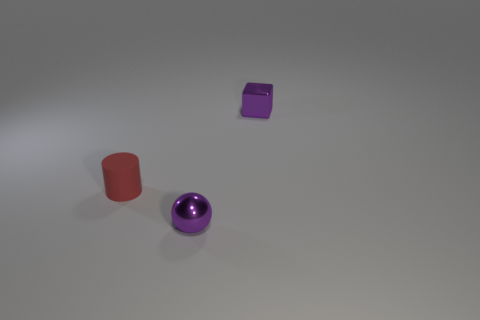What number of red cylinders are the same size as the metal block?
Make the answer very short. 1. How many metallic objects are either big cyan things or tiny purple blocks?
Give a very brief answer. 1. There is a metallic object that is the same color as the small shiny cube; what size is it?
Offer a terse response. Small. There is a tiny purple object in front of the small purple metal object behind the small red matte object; what is it made of?
Make the answer very short. Metal. How many things are either shiny blocks or metal objects that are in front of the red cylinder?
Your answer should be compact. 2. What is the size of the purple sphere that is the same material as the cube?
Your answer should be compact. Small. What number of cyan things are either tiny metallic objects or tiny metallic blocks?
Offer a terse response. 0. There is a tiny thing that is the same color as the small block; what shape is it?
Provide a succinct answer. Sphere. Is there anything else that is the same material as the tiny sphere?
Your answer should be compact. Yes. Do the thing that is behind the red rubber cylinder and the metallic object in front of the small red thing have the same shape?
Offer a terse response. No. 